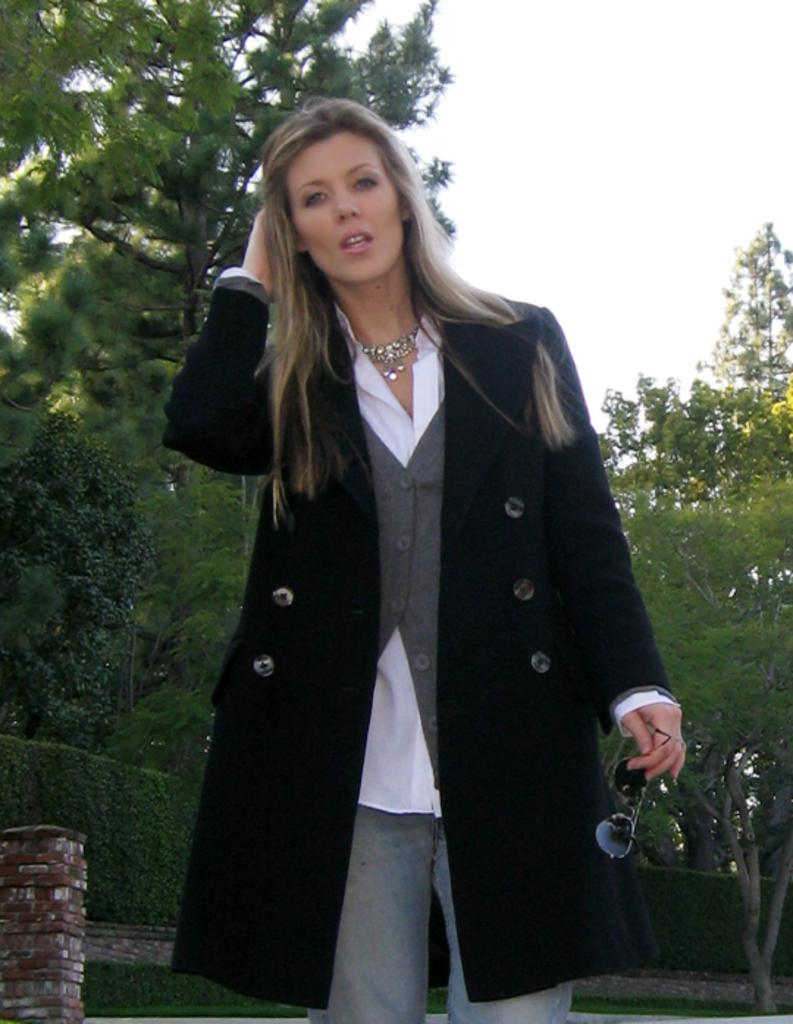What is the woman in the image doing? The woman is standing in the image and holding glasses. What type of surface is visible in the image? There is grass visible in the image. What other types of vegetation can be seen in the image? There are plants and trees in the image. What part of the natural environment is visible in the image? The sky is visible in the image. Can you tell me how the woman is using the paste in the image? There is no paste present in the image, so it cannot be used by the woman. 